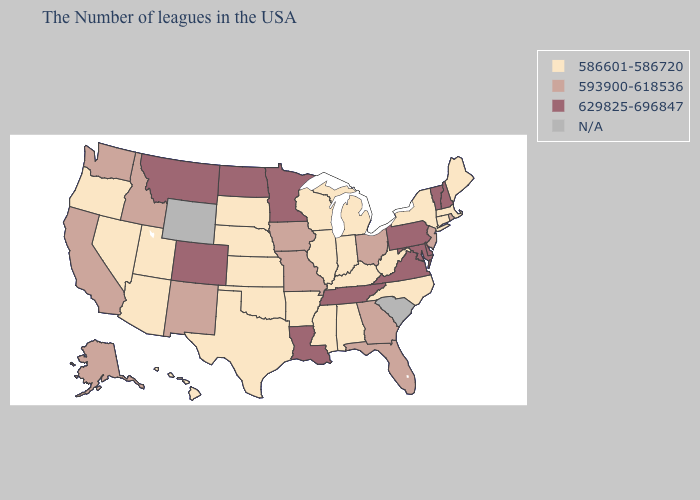How many symbols are there in the legend?
Quick response, please. 4. Does Mississippi have the lowest value in the USA?
Answer briefly. Yes. Which states hav the highest value in the South?
Quick response, please. Delaware, Maryland, Virginia, Tennessee, Louisiana. What is the value of Indiana?
Be succinct. 586601-586720. Does North Carolina have the highest value in the South?
Concise answer only. No. Which states have the lowest value in the MidWest?
Give a very brief answer. Michigan, Indiana, Wisconsin, Illinois, Kansas, Nebraska, South Dakota. Name the states that have a value in the range 586601-586720?
Write a very short answer. Maine, Massachusetts, Connecticut, New York, North Carolina, West Virginia, Michigan, Kentucky, Indiana, Alabama, Wisconsin, Illinois, Mississippi, Arkansas, Kansas, Nebraska, Oklahoma, Texas, South Dakota, Utah, Arizona, Nevada, Oregon, Hawaii. What is the value of Montana?
Short answer required. 629825-696847. Among the states that border Missouri , which have the highest value?
Be succinct. Tennessee. Is the legend a continuous bar?
Be succinct. No. Does the first symbol in the legend represent the smallest category?
Answer briefly. Yes. Is the legend a continuous bar?
Write a very short answer. No. Does Colorado have the highest value in the West?
Keep it brief. Yes. What is the highest value in the USA?
Concise answer only. 629825-696847. 